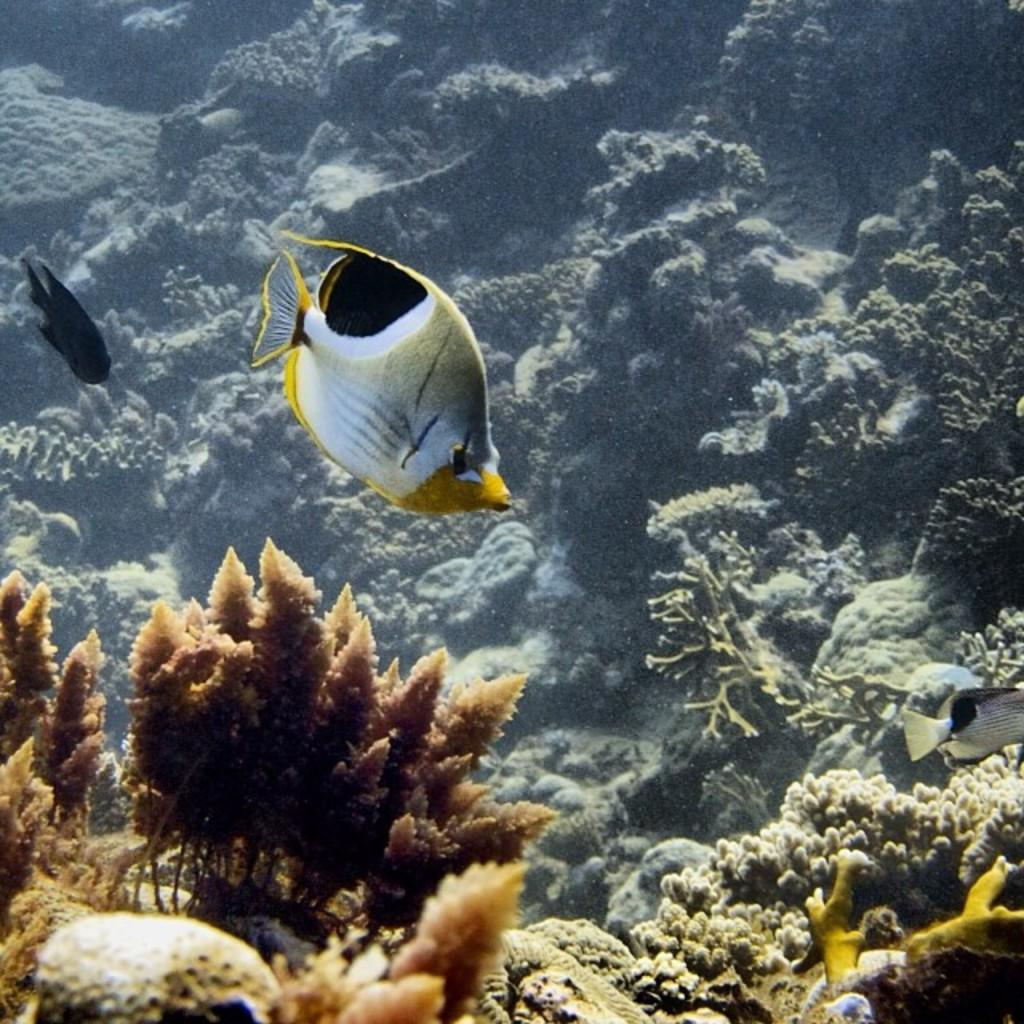What is the setting of the image? The image is taken underwater. What types of marine animals can be seen in the image? There are fishes swimming in the water. What is located at the bottom of the image? There are coral reefs at the bottom of the image. What can be seen in the background of the image? Marine plants are visible in the background of the image. What type of treatment is being administered to the pear in the image? There is no pear present in the image; it is an underwater scene with fishes, coral reefs, and marine plants. 